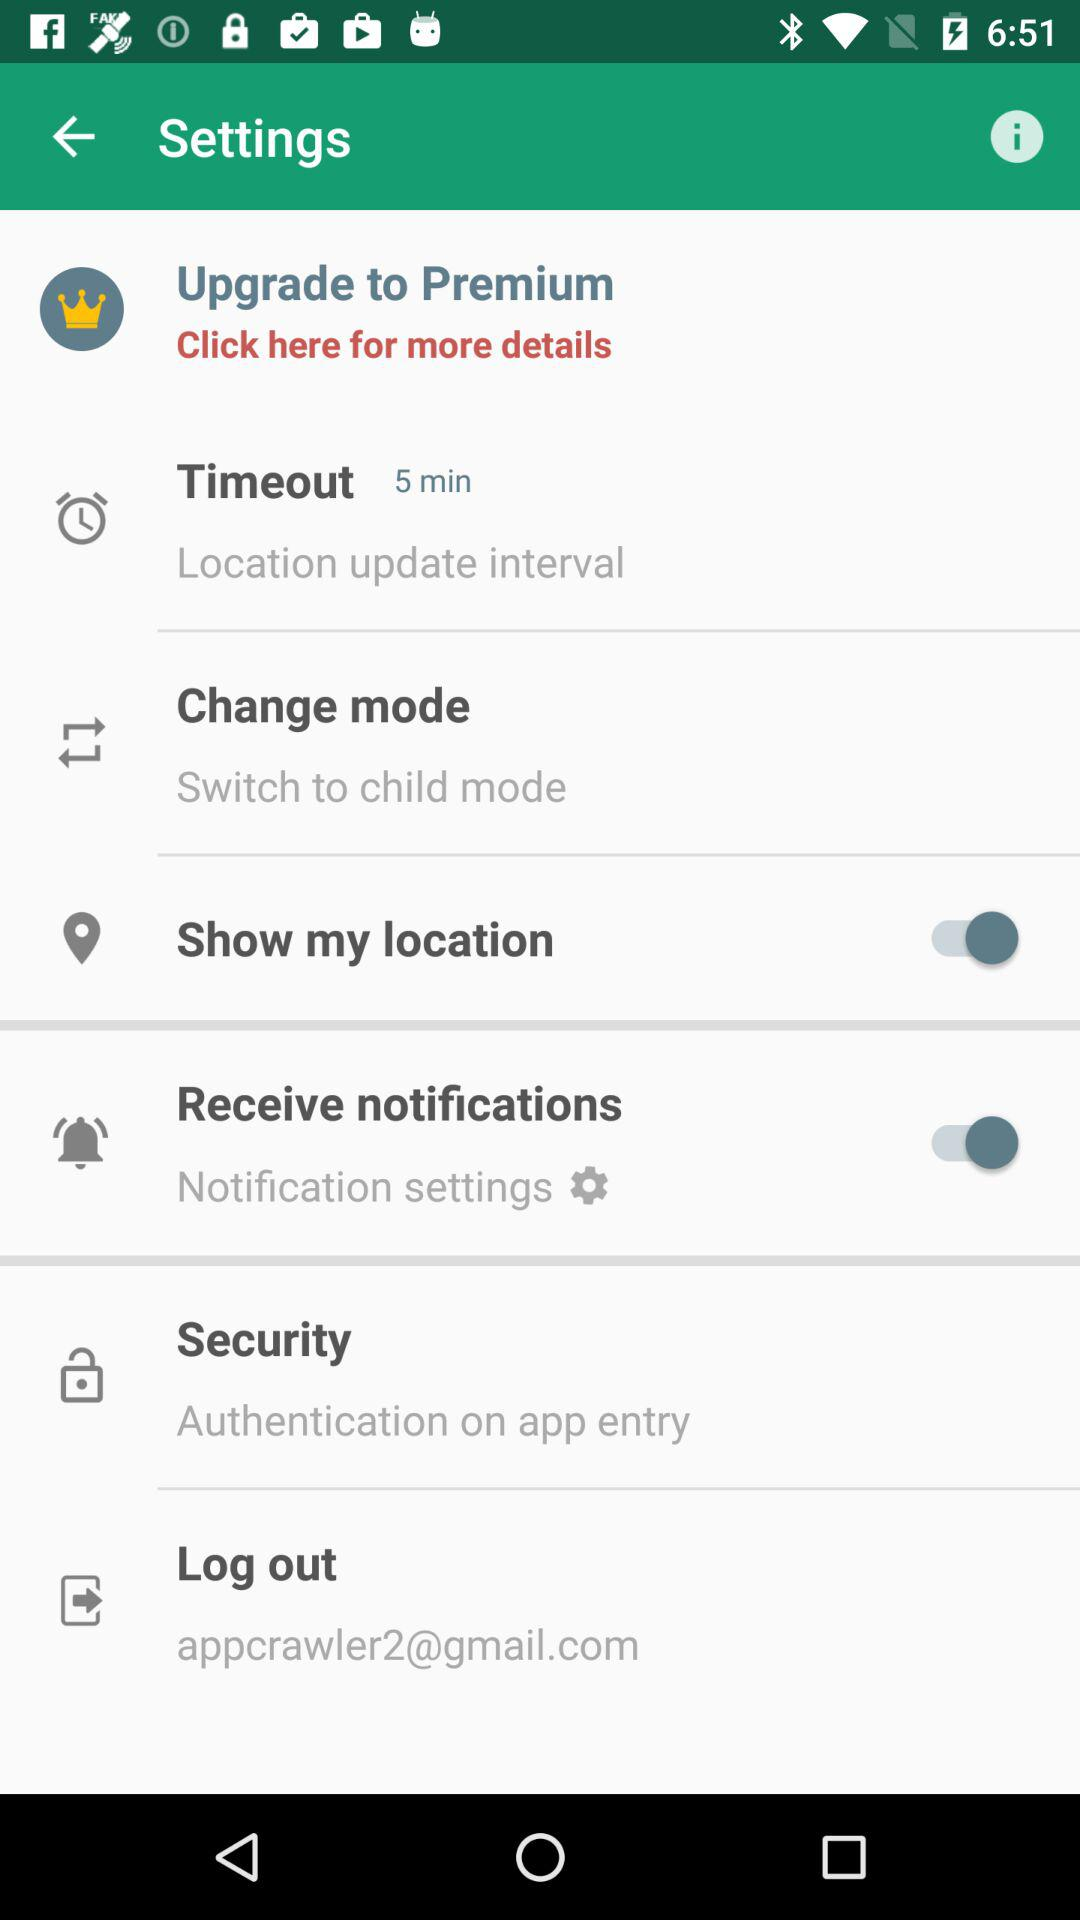What is the status of "Receive notifications"? The status is "on". 